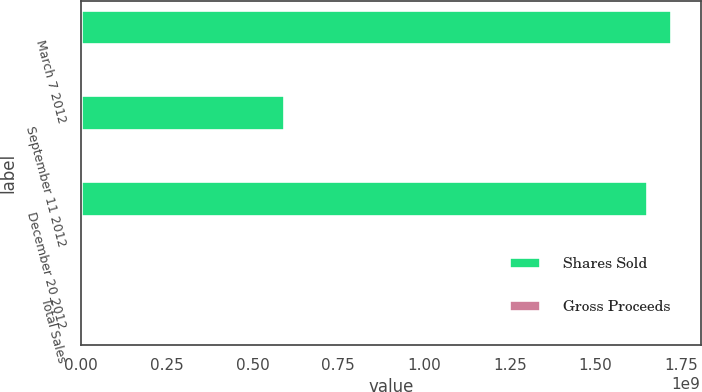Convert chart. <chart><loc_0><loc_0><loc_500><loc_500><stacked_bar_chart><ecel><fcel>March 7 2012<fcel>September 11 2012<fcel>December 20 2012<fcel>Total Sales<nl><fcel>Shares Sold<fcel>1.72e+09<fcel>5.91866e+08<fcel>1.6489e+09<fcel>14.5<nl><fcel>Gross Proceeds<fcel>6<fcel>2<fcel>6.5<fcel>14.5<nl></chart> 